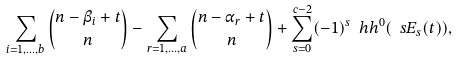Convert formula to latex. <formula><loc_0><loc_0><loc_500><loc_500>\sum _ { i = 1 , \dots , b } { { n - \beta _ { i } + t } \choose n } - \sum _ { r = 1 , \dots , a } { { n - \alpha _ { r } + t } \choose n } + \sum _ { s = 0 } ^ { c - 2 } ( - 1 ) ^ { s } \ h h ^ { 0 } ( \ s E _ { s } ( t ) ) ,</formula> 